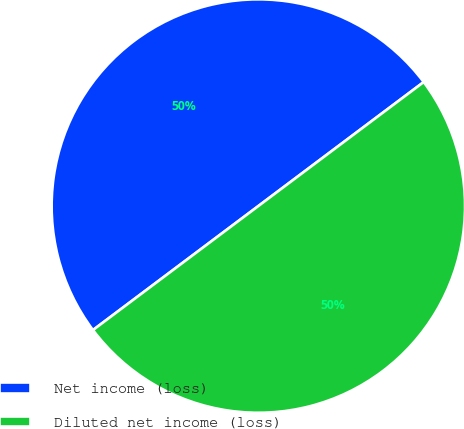Convert chart. <chart><loc_0><loc_0><loc_500><loc_500><pie_chart><fcel>Net income (loss)<fcel>Diluted net income (loss)<nl><fcel>50.0%<fcel>50.0%<nl></chart> 